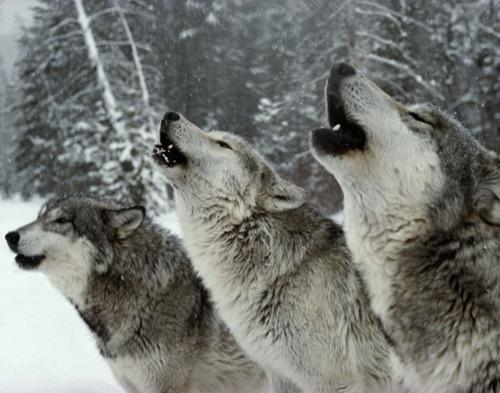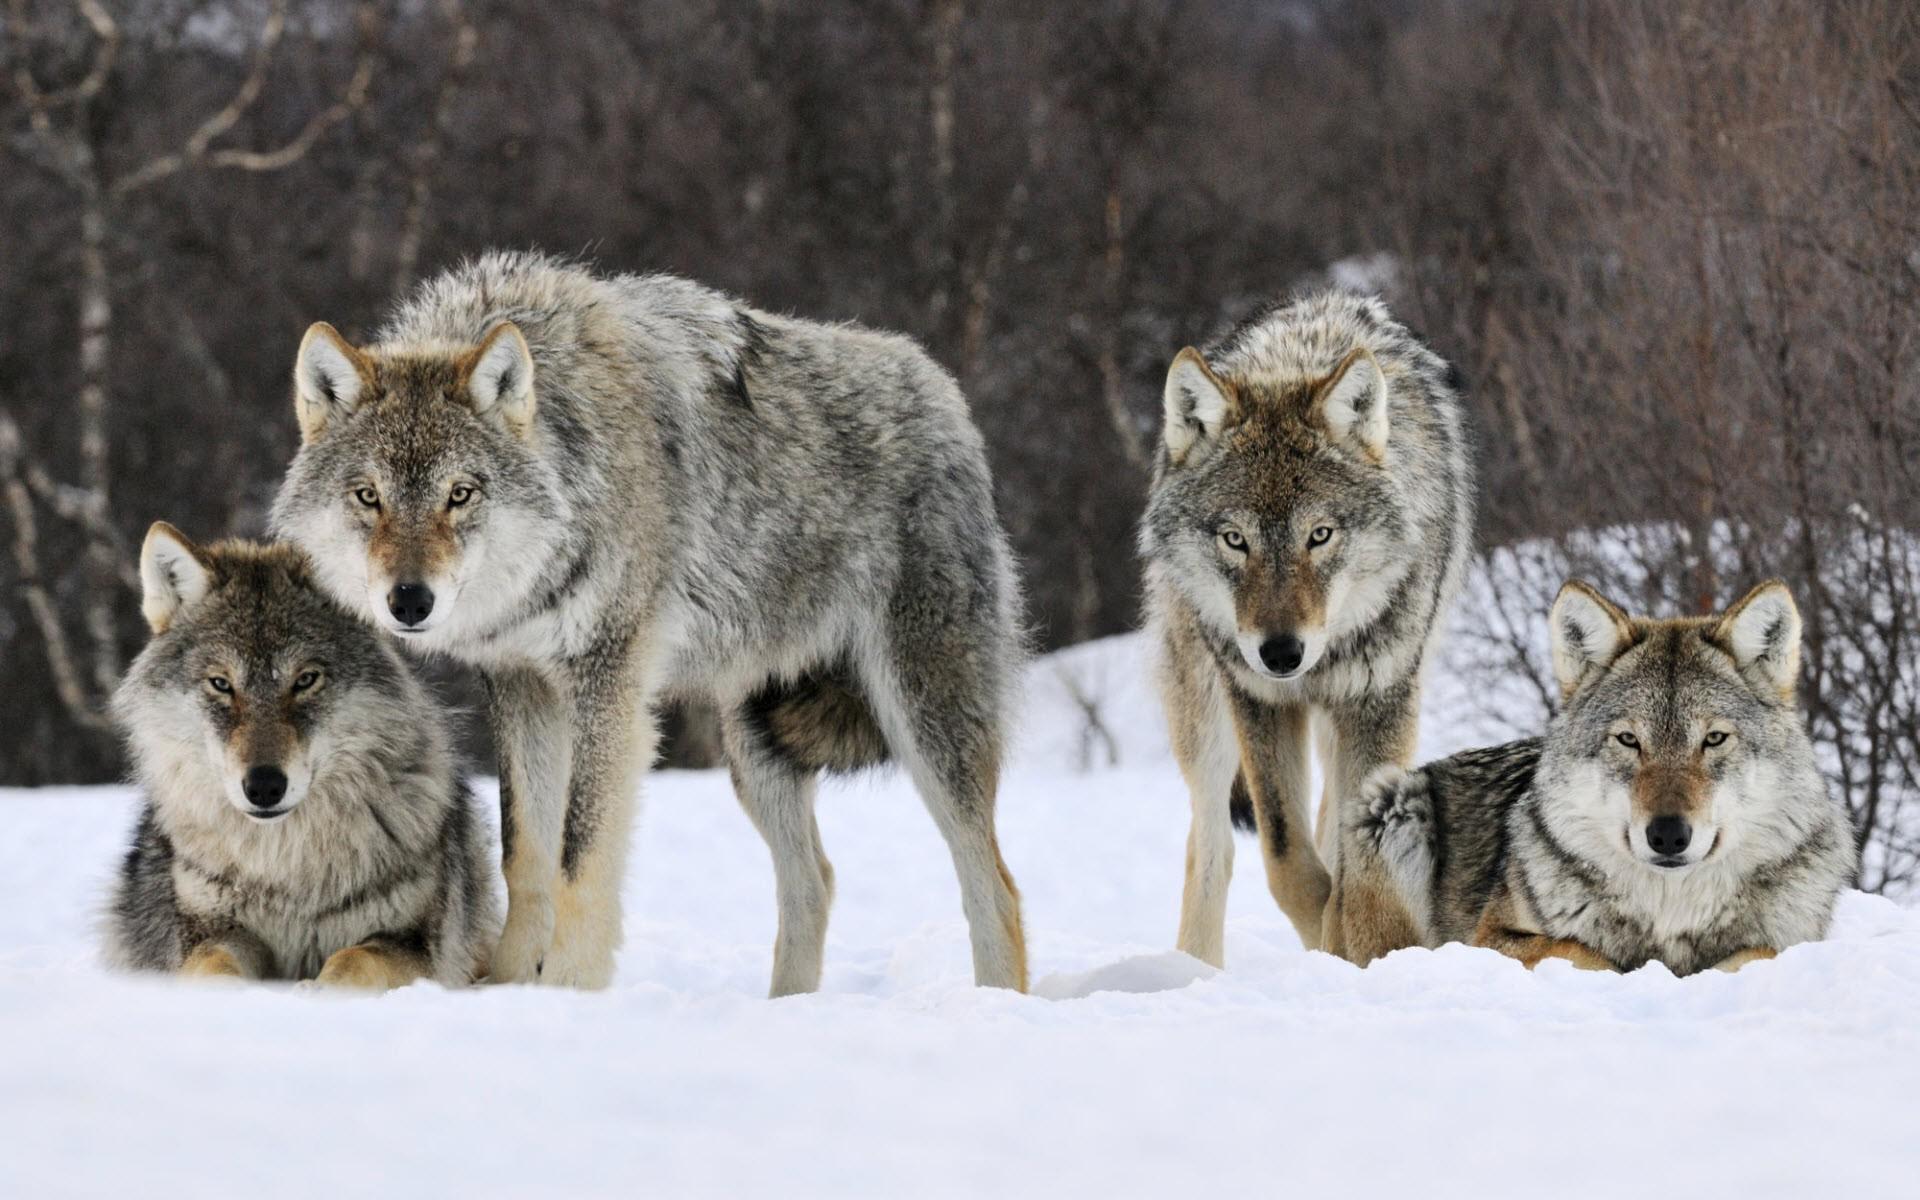The first image is the image on the left, the second image is the image on the right. Considering the images on both sides, is "Each dog is howling in the snow." valid? Answer yes or no. No. The first image is the image on the left, the second image is the image on the right. Considering the images on both sides, is "All wolves are howling, all scenes contain snow, and no image contains more than one wolf." valid? Answer yes or no. No. 